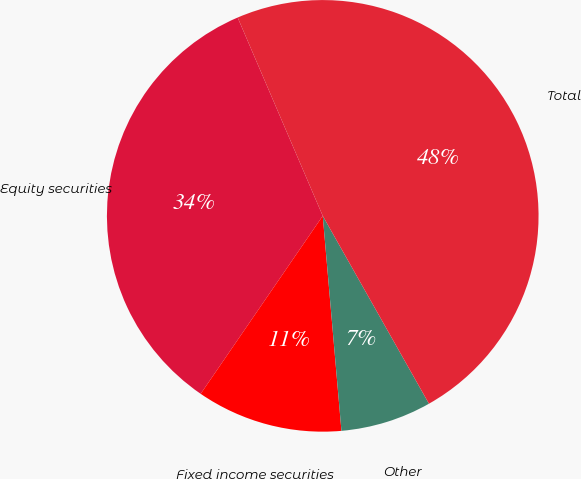<chart> <loc_0><loc_0><loc_500><loc_500><pie_chart><fcel>Equity securities<fcel>Fixed income securities<fcel>Other<fcel>Total<nl><fcel>33.98%<fcel>10.95%<fcel>6.81%<fcel>48.26%<nl></chart> 